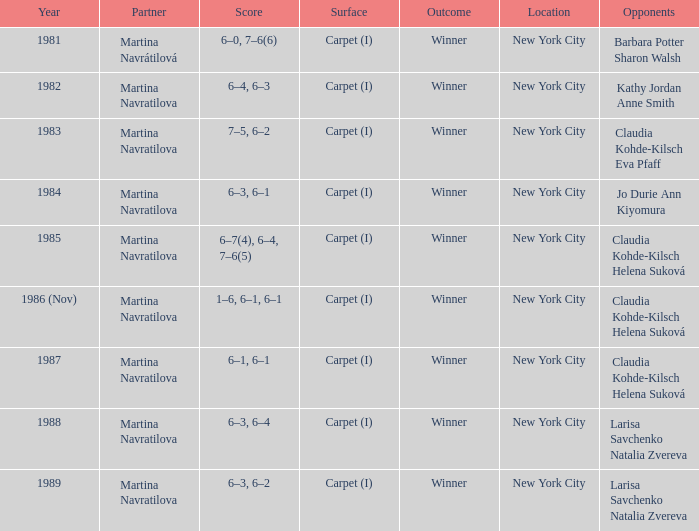How many locations hosted Claudia Kohde-Kilsch Eva Pfaff? 1.0. 